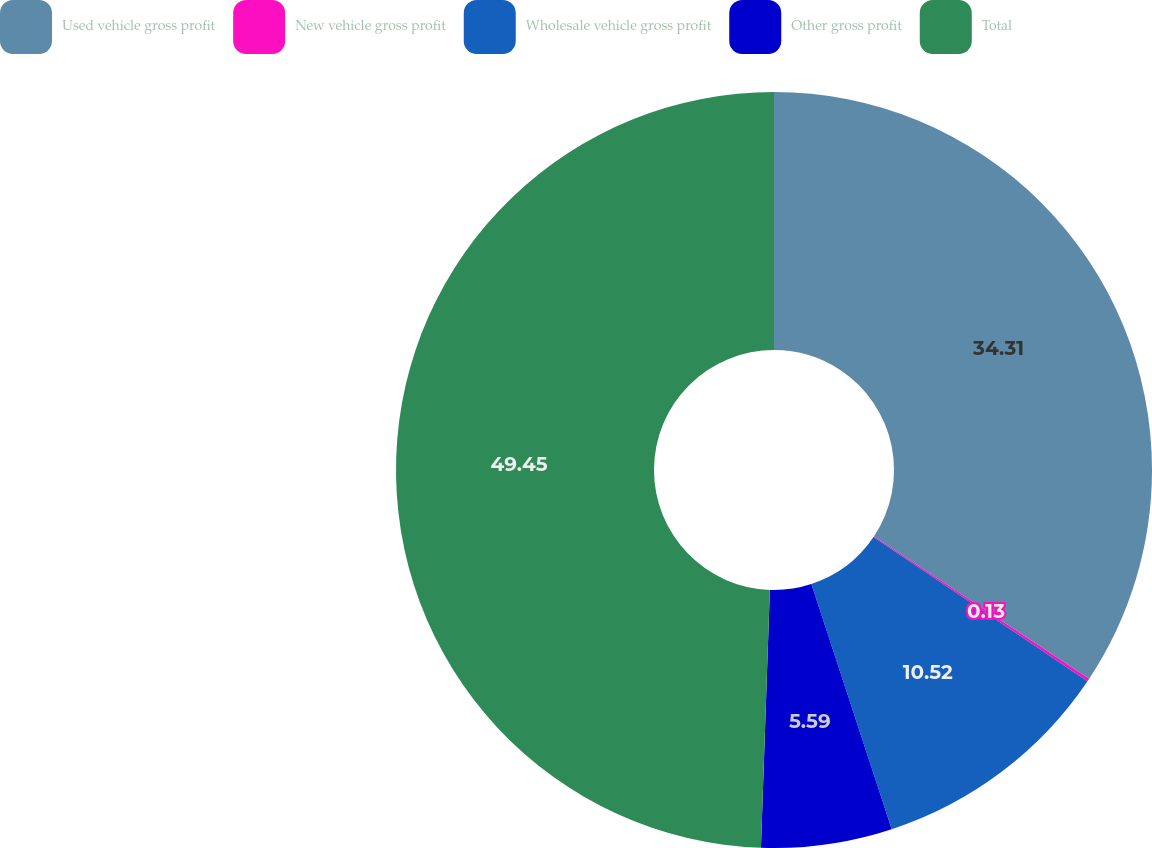Convert chart. <chart><loc_0><loc_0><loc_500><loc_500><pie_chart><fcel>Used vehicle gross profit<fcel>New vehicle gross profit<fcel>Wholesale vehicle gross profit<fcel>Other gross profit<fcel>Total<nl><fcel>34.3%<fcel>0.13%<fcel>10.52%<fcel>5.59%<fcel>49.44%<nl></chart> 